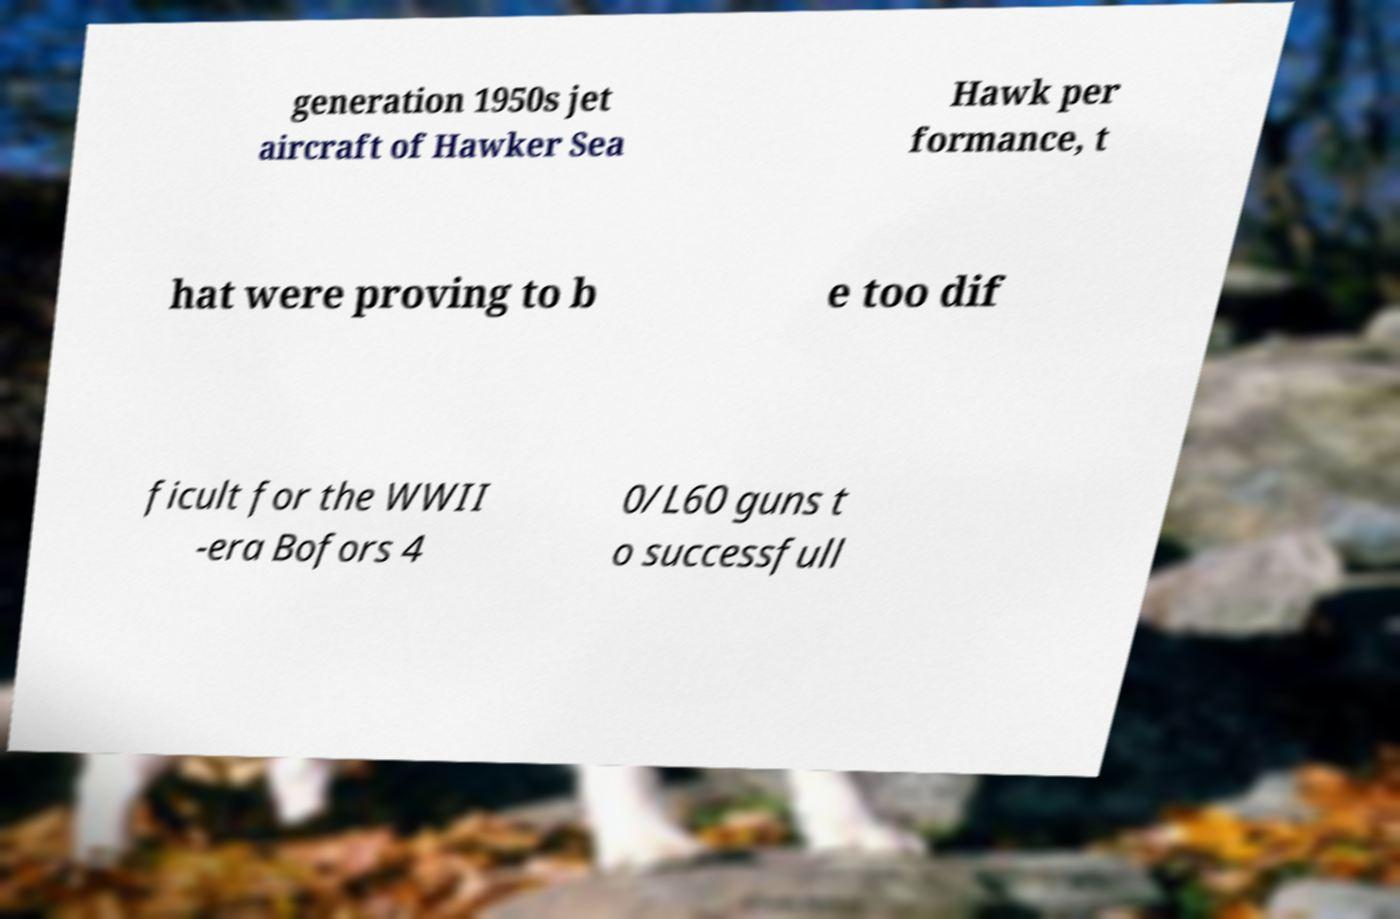There's text embedded in this image that I need extracted. Can you transcribe it verbatim? generation 1950s jet aircraft of Hawker Sea Hawk per formance, t hat were proving to b e too dif ficult for the WWII -era Bofors 4 0/L60 guns t o successfull 